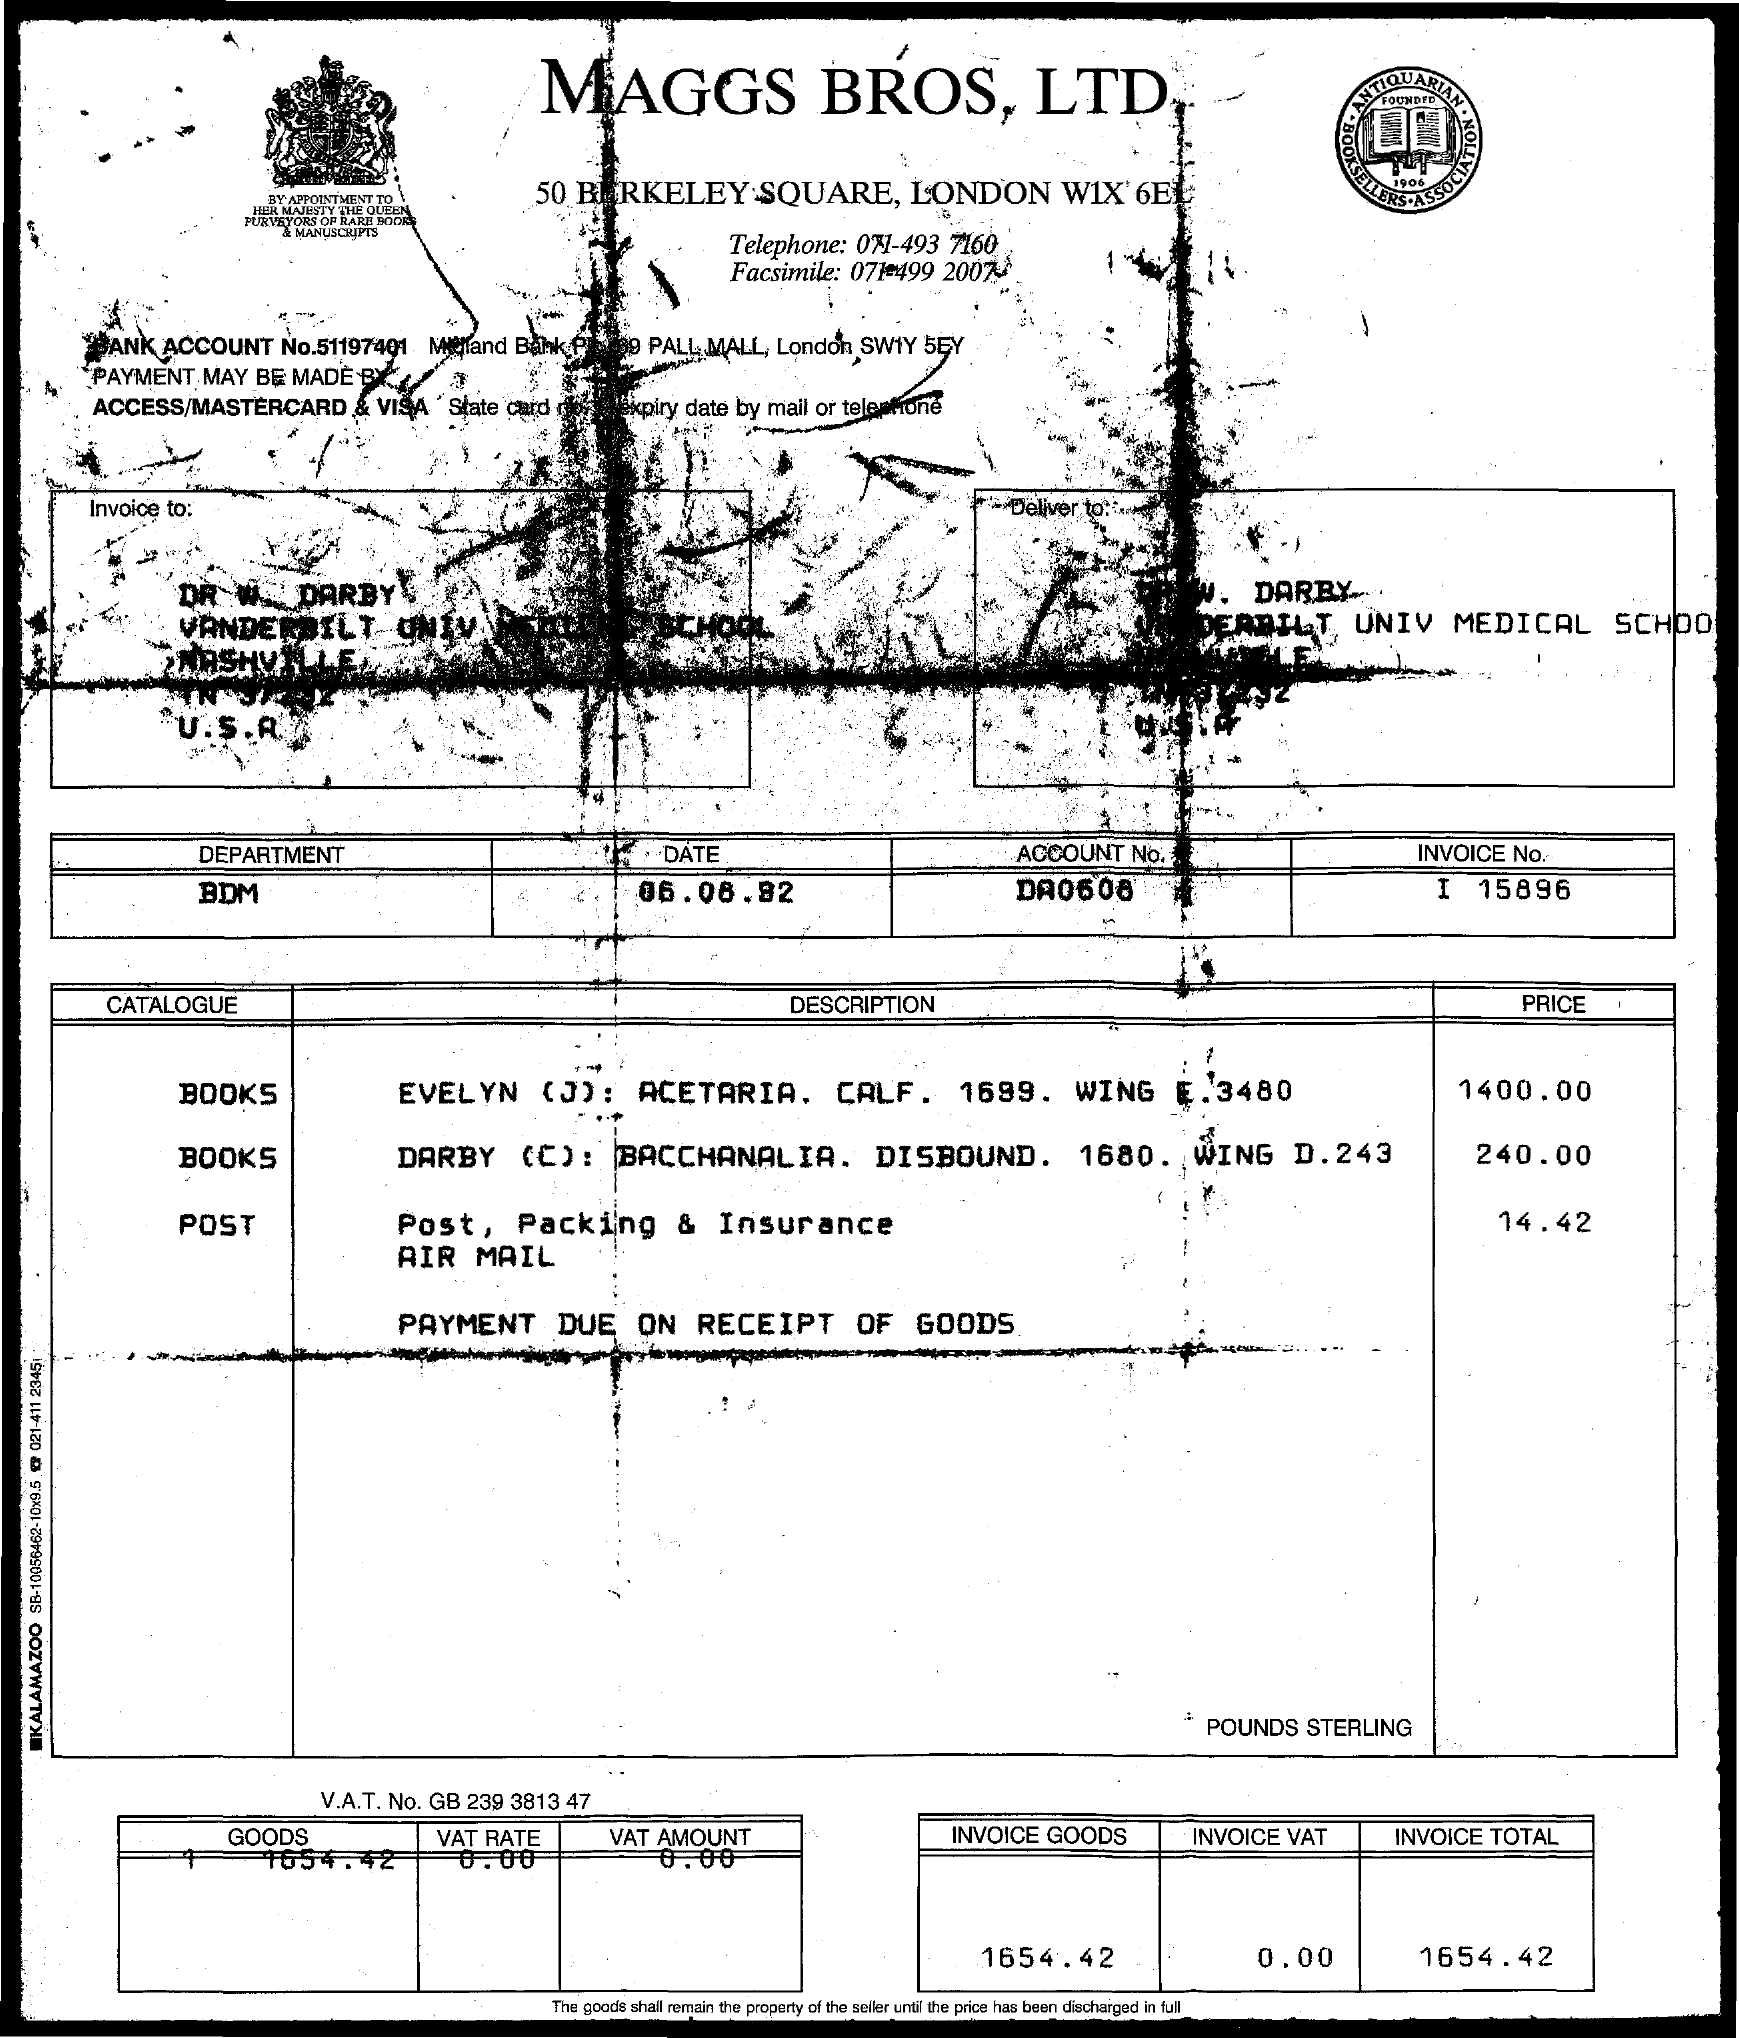What is the title of the document?
Offer a terse response. Maggs bros, ltd. What is the Account Number?
Offer a very short reply. Da0608. What is the Bank Account No.?
Your answer should be very brief. 51197401. What is the Invoice No.?
Keep it short and to the point. I 15896. What is the Invoice Total?
Your response must be concise. 1654.42. What is the Department Name?
Make the answer very short. Bdm. What is the V.A.T No.?
Provide a succinct answer. Gb 239 3813 47. What is the telephone number?
Your response must be concise. 071-493 7160. What is the Facsimile number?
Keep it short and to the point. 071-499 2007. 